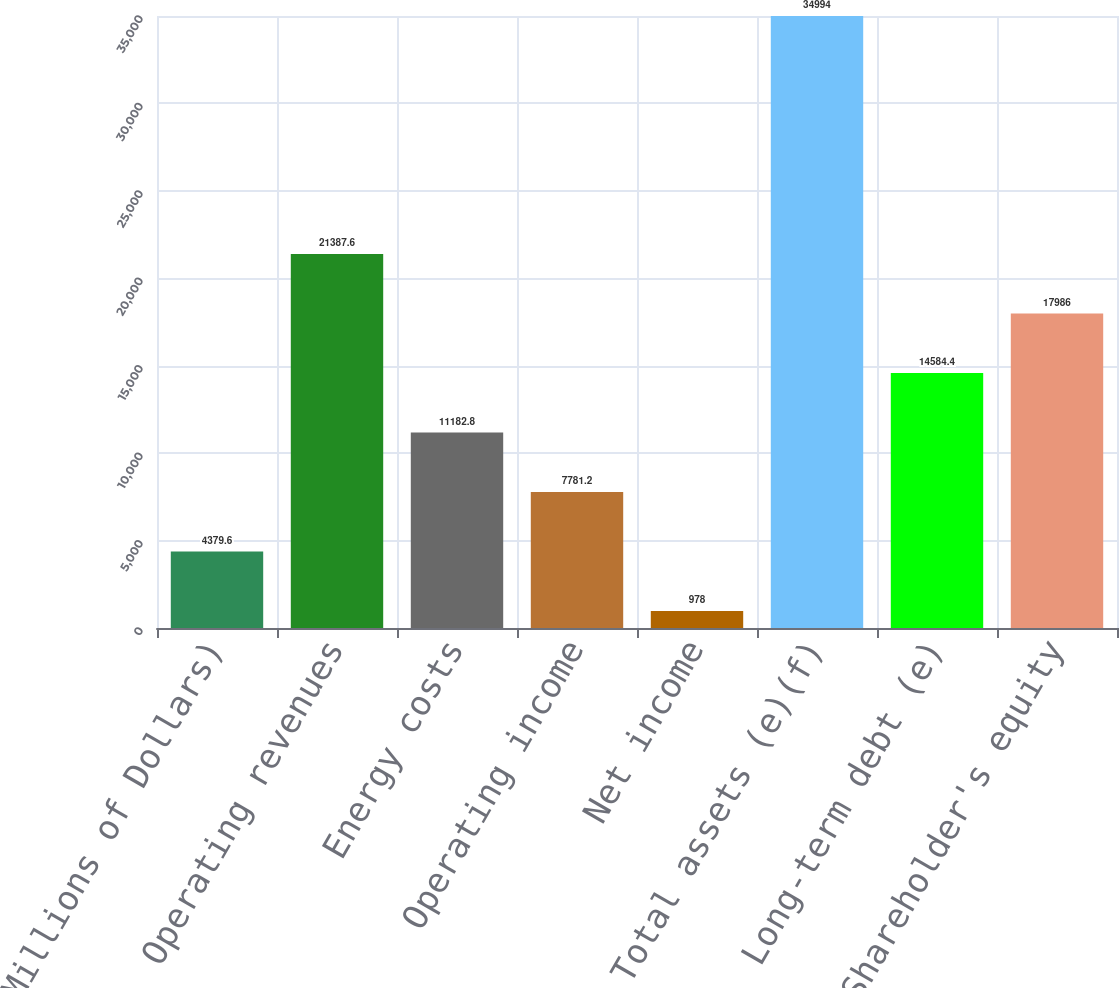Convert chart to OTSL. <chart><loc_0><loc_0><loc_500><loc_500><bar_chart><fcel>(Millions of Dollars)<fcel>Operating revenues<fcel>Energy costs<fcel>Operating income<fcel>Net income<fcel>Total assets (e)(f)<fcel>Long-term debt (e)<fcel>Shareholder's equity<nl><fcel>4379.6<fcel>21387.6<fcel>11182.8<fcel>7781.2<fcel>978<fcel>34994<fcel>14584.4<fcel>17986<nl></chart> 